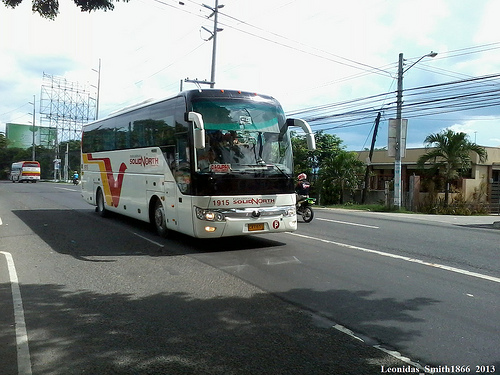Please provide the bounding box coordinate of the region this sentence describes: a motorcycle next to bus. The bounding box for the region showing a motorcycle next to a bus should be approximately from (0.58, 0.44) to (0.67, 0.63). 